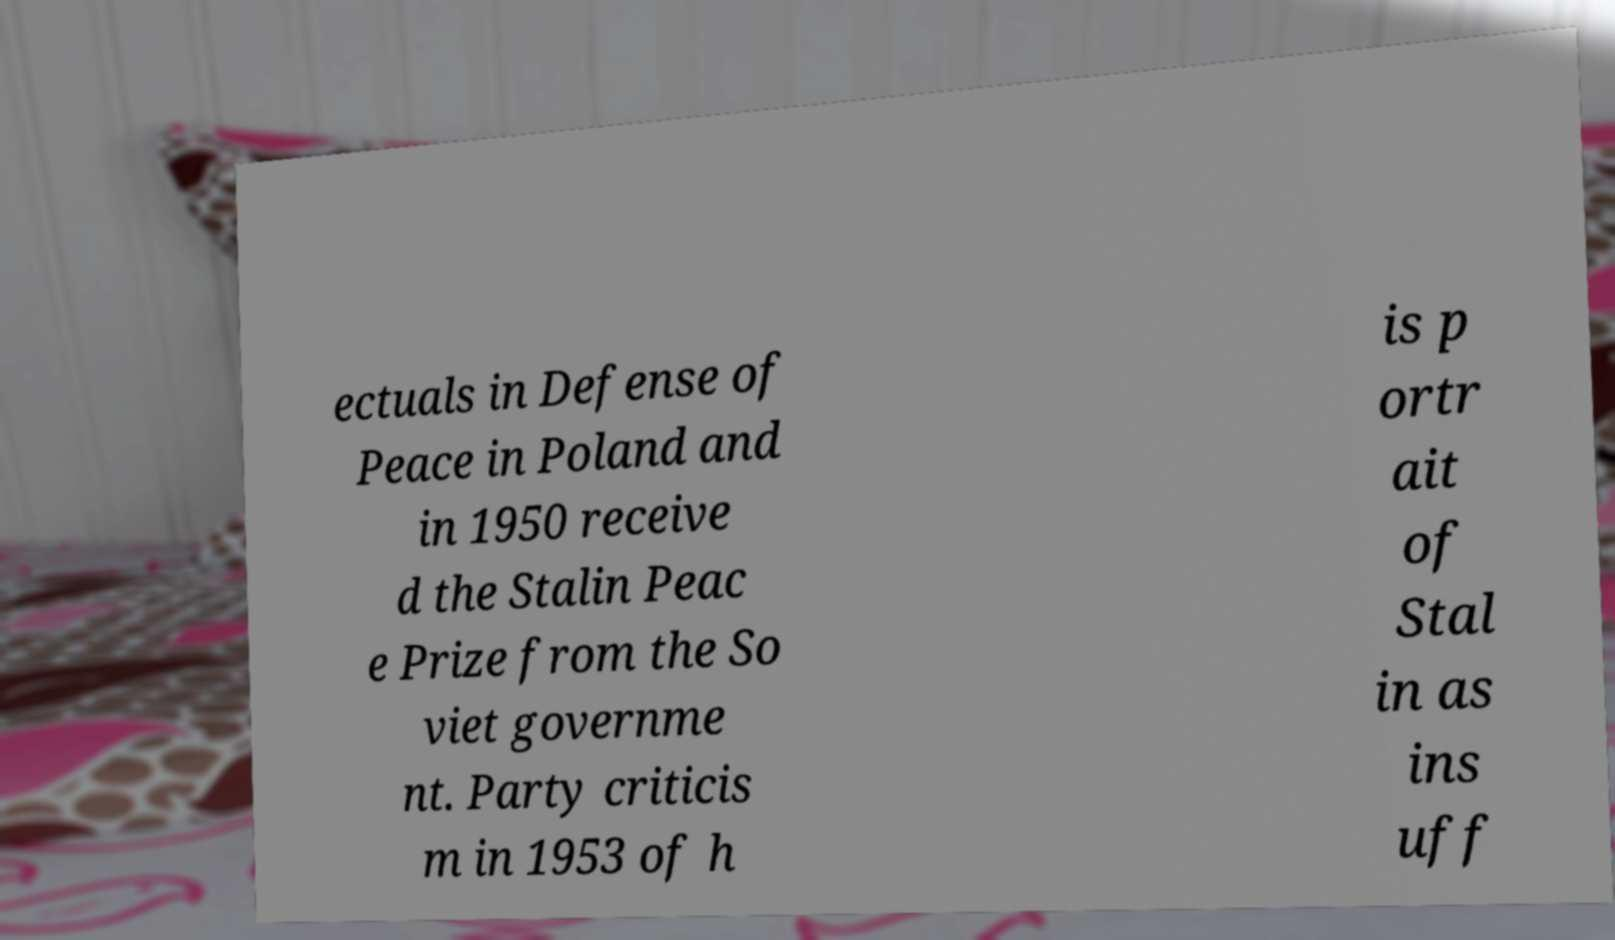Can you read and provide the text displayed in the image?This photo seems to have some interesting text. Can you extract and type it out for me? ectuals in Defense of Peace in Poland and in 1950 receive d the Stalin Peac e Prize from the So viet governme nt. Party criticis m in 1953 of h is p ortr ait of Stal in as ins uff 